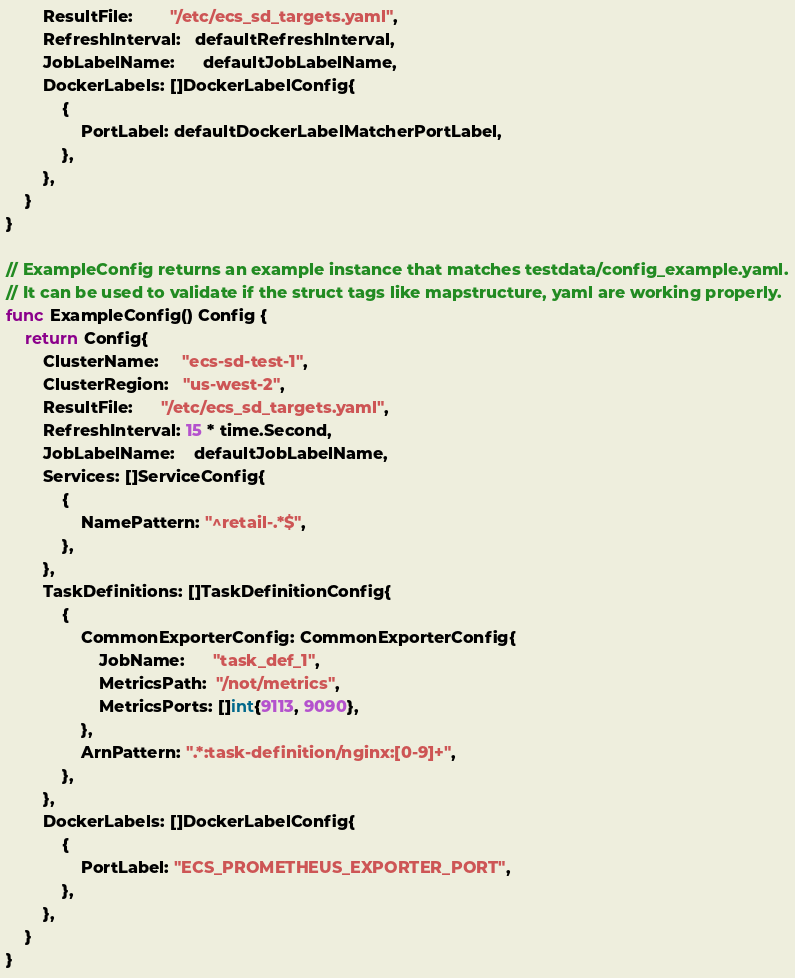<code> <loc_0><loc_0><loc_500><loc_500><_Go_>		ResultFile:        "/etc/ecs_sd_targets.yaml",
		RefreshInterval:   defaultRefreshInterval,
		JobLabelName:      defaultJobLabelName,
		DockerLabels: []DockerLabelConfig{
			{
				PortLabel: defaultDockerLabelMatcherPortLabel,
			},
		},
	}
}

// ExampleConfig returns an example instance that matches testdata/config_example.yaml.
// It can be used to validate if the struct tags like mapstructure, yaml are working properly.
func ExampleConfig() Config {
	return Config{
		ClusterName:     "ecs-sd-test-1",
		ClusterRegion:   "us-west-2",
		ResultFile:      "/etc/ecs_sd_targets.yaml",
		RefreshInterval: 15 * time.Second,
		JobLabelName:    defaultJobLabelName,
		Services: []ServiceConfig{
			{
				NamePattern: "^retail-.*$",
			},
		},
		TaskDefinitions: []TaskDefinitionConfig{
			{
				CommonExporterConfig: CommonExporterConfig{
					JobName:      "task_def_1",
					MetricsPath:  "/not/metrics",
					MetricsPorts: []int{9113, 9090},
				},
				ArnPattern: ".*:task-definition/nginx:[0-9]+",
			},
		},
		DockerLabels: []DockerLabelConfig{
			{
				PortLabel: "ECS_PROMETHEUS_EXPORTER_PORT",
			},
		},
	}
}
</code> 